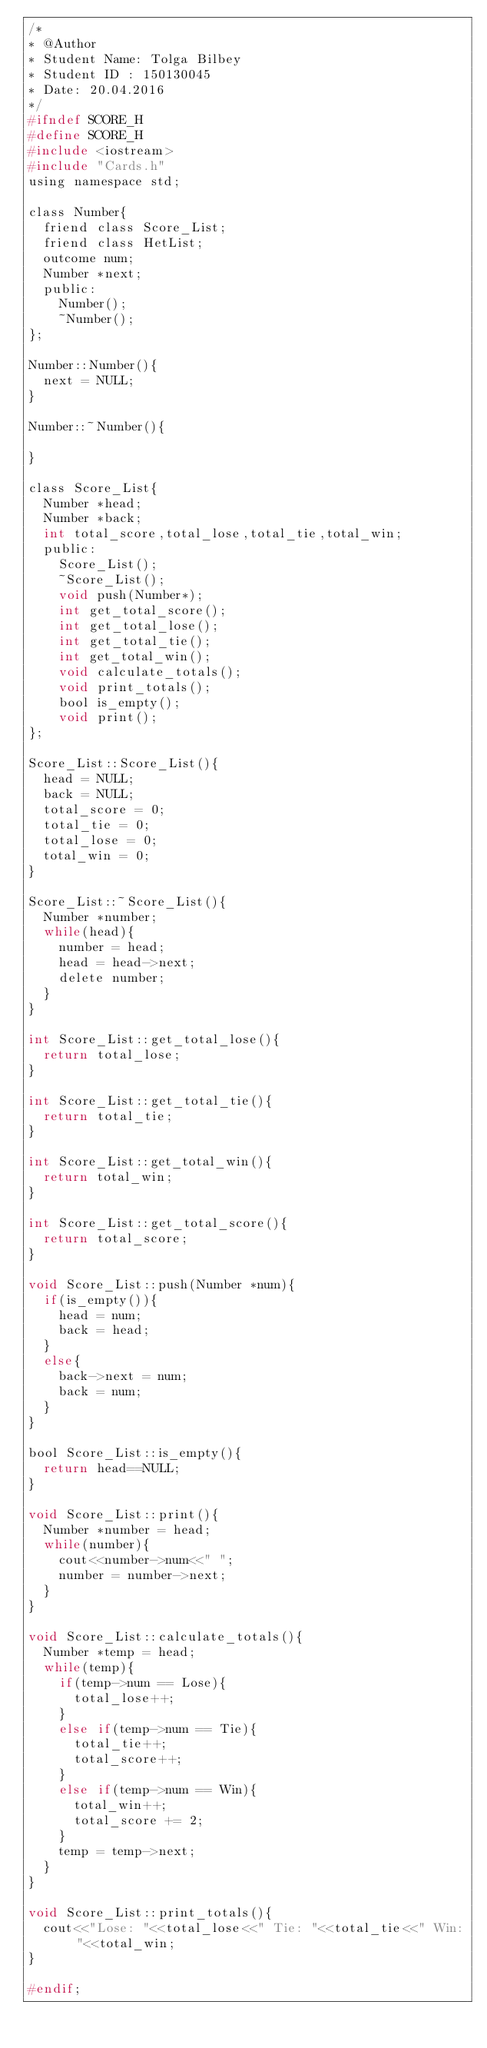<code> <loc_0><loc_0><loc_500><loc_500><_C_>/*
* @Author
* Student Name: Tolga Bilbey
* Student ID : 150130045
* Date: 20.04.2016
*/
#ifndef SCORE_H
#define SCORE_H
#include <iostream>
#include "Cards.h"
using namespace std;

class Number{
	friend class Score_List;
	friend class HetList;
	outcome num;
	Number *next;
	public:
		Number();
		~Number();
};

Number::Number(){
	next = NULL;
}

Number::~Number(){
	
}

class Score_List{
	Number *head;
	Number *back;
	int total_score,total_lose,total_tie,total_win;
	public:
		Score_List();
		~Score_List();
		void push(Number*);
		int get_total_score();
		int get_total_lose();
		int get_total_tie();
		int get_total_win();
		void calculate_totals();
		void print_totals();
		bool is_empty();
		void print();
};

Score_List::Score_List(){
	head = NULL;
	back = NULL;
	total_score = 0;
	total_tie = 0;
	total_lose = 0;
	total_win = 0;
}

Score_List::~Score_List(){
	Number *number;
	while(head){
		number = head;
		head = head->next;
		delete number;
	}
}

int Score_List::get_total_lose(){
	return total_lose;
}

int Score_List::get_total_tie(){
	return total_tie;
}

int Score_List::get_total_win(){
	return total_win;
}

int Score_List::get_total_score(){
	return total_score;
}

void Score_List::push(Number *num){
	if(is_empty()){
		head = num;
		back = head;
	}
	else{
		back->next = num;
		back = num;
	}
}

bool Score_List::is_empty(){
	return head==NULL;
}

void Score_List::print(){
	Number *number = head;
	while(number){
		cout<<number->num<<" ";
		number = number->next;
	}
}

void Score_List::calculate_totals(){
	Number *temp = head;
	while(temp){
		if(temp->num == Lose){
			total_lose++;
		}
		else if(temp->num == Tie){
			total_tie++;
			total_score++;
		}
		else if(temp->num == Win){
			total_win++;
			total_score += 2;
		}
		temp = temp->next;
	}
}

void Score_List::print_totals(){
	cout<<"Lose: "<<total_lose<<" Tie: "<<total_tie<<" Win: "<<total_win;
}

#endif;</code> 